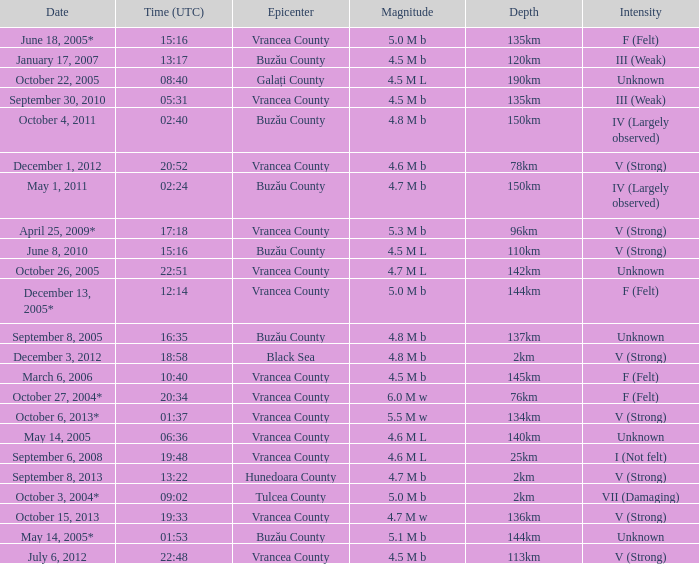Give me the full table as a dictionary. {'header': ['Date', 'Time (UTC)', 'Epicenter', 'Magnitude', 'Depth', 'Intensity'], 'rows': [['June 18, 2005*', '15:16', 'Vrancea County', '5.0 M b', '135km', 'F (Felt)'], ['January 17, 2007', '13:17', 'Buzău County', '4.5 M b', '120km', 'III (Weak)'], ['October 22, 2005', '08:40', 'Galați County', '4.5 M L', '190km', 'Unknown'], ['September 30, 2010', '05:31', 'Vrancea County', '4.5 M b', '135km', 'III (Weak)'], ['October 4, 2011', '02:40', 'Buzău County', '4.8 M b', '150km', 'IV (Largely observed)'], ['December 1, 2012', '20:52', 'Vrancea County', '4.6 M b', '78km', 'V (Strong)'], ['May 1, 2011', '02:24', 'Buzău County', '4.7 M b', '150km', 'IV (Largely observed)'], ['April 25, 2009*', '17:18', 'Vrancea County', '5.3 M b', '96km', 'V (Strong)'], ['June 8, 2010', '15:16', 'Buzău County', '4.5 M L', '110km', 'V (Strong)'], ['October 26, 2005', '22:51', 'Vrancea County', '4.7 M L', '142km', 'Unknown'], ['December 13, 2005*', '12:14', 'Vrancea County', '5.0 M b', '144km', 'F (Felt)'], ['September 8, 2005', '16:35', 'Buzău County', '4.8 M b', '137km', 'Unknown'], ['December 3, 2012', '18:58', 'Black Sea', '4.8 M b', '2km', 'V (Strong)'], ['March 6, 2006', '10:40', 'Vrancea County', '4.5 M b', '145km', 'F (Felt)'], ['October 27, 2004*', '20:34', 'Vrancea County', '6.0 M w', '76km', 'F (Felt)'], ['October 6, 2013*', '01:37', 'Vrancea County', '5.5 M w', '134km', 'V (Strong)'], ['May 14, 2005', '06:36', 'Vrancea County', '4.6 M L', '140km', 'Unknown'], ['September 6, 2008', '19:48', 'Vrancea County', '4.6 M L', '25km', 'I (Not felt)'], ['September 8, 2013', '13:22', 'Hunedoara County', '4.7 M b', '2km', 'V (Strong)'], ['October 3, 2004*', '09:02', 'Tulcea County', '5.0 M b', '2km', 'VII (Damaging)'], ['October 15, 2013', '19:33', 'Vrancea County', '4.7 M w', '136km', 'V (Strong)'], ['May 14, 2005*', '01:53', 'Buzău County', '5.1 M b', '144km', 'Unknown'], ['July 6, 2012', '22:48', 'Vrancea County', '4.5 M b', '113km', 'V (Strong)']]} What is the depth of the quake that occurred at 19:48? 25km. 